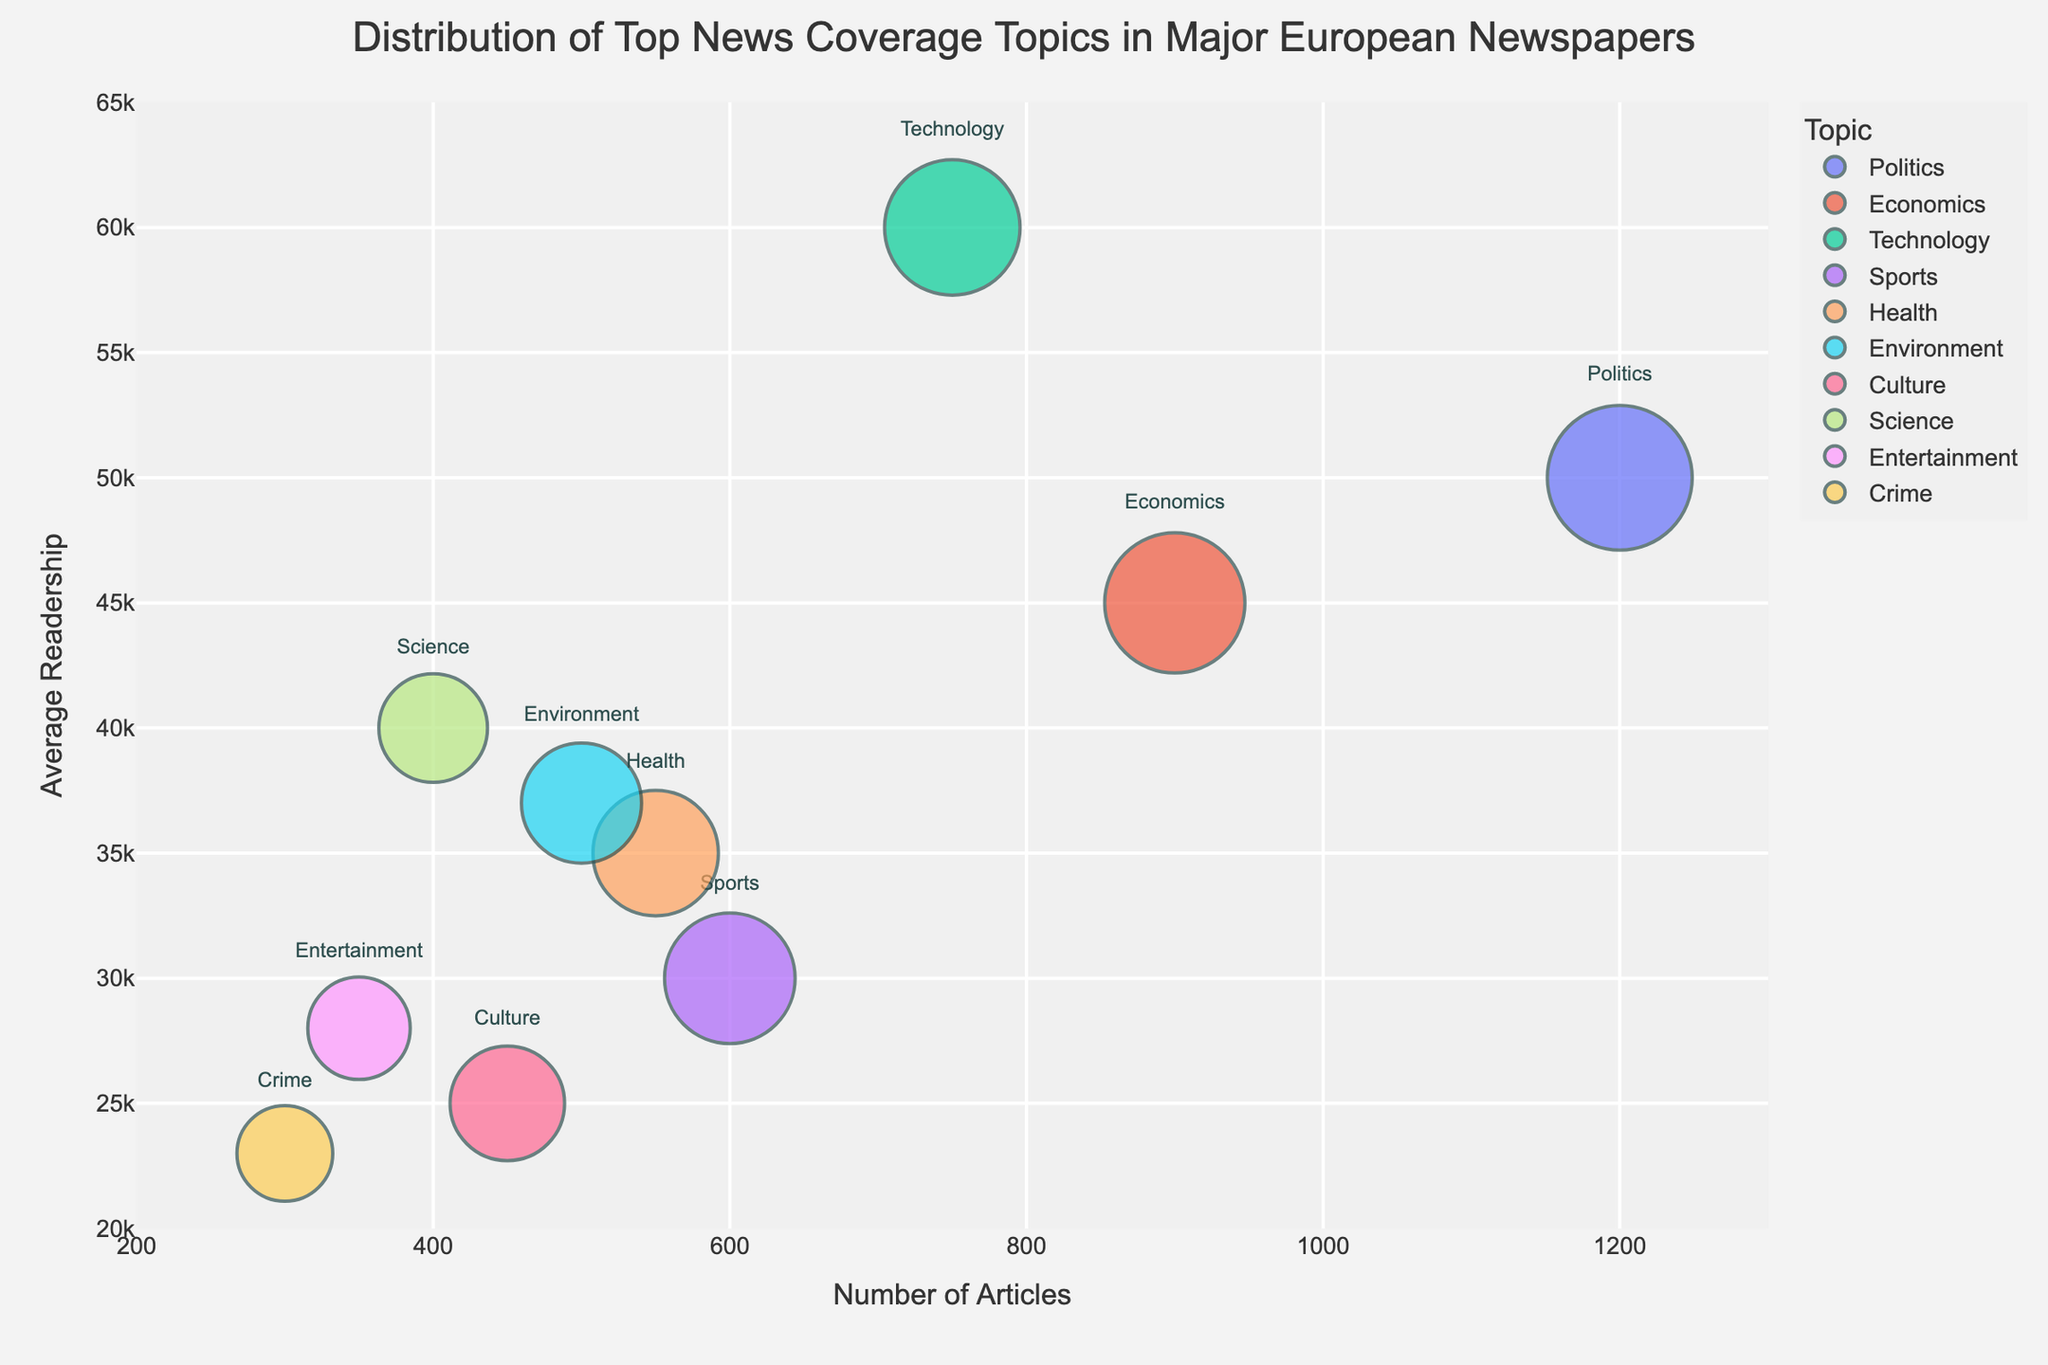what is the title of the figure? The title is usually placed at the top of the figure. In this case, it reads "Distribution of Top News Coverage Topics in Major European Newspapers".
Answer: Distribution of Top News Coverage Topics in Major European Newspapers how many topics have exactly 600 articles? Looking for the "Number of Articles" value in the figure, there is one bubble representing 'Sports' with exactly 600 articles.
Answer: 1 which topic has the highest average readership, and what is the value? To find the highest average readership, look on the y-axis. The topic 'Technology' has the highest average readership of 60,000.
Answer: Technology, 60000 what is the average impact score of 'Health' and 'Environment' topics? Firstly, note the impact scores for 'Health' (60) and 'Environment' (55). Then, calculate (60 + 55) / 2 = 57.5.
Answer: 57.5 which two topics have the closest number of articles, and what are those numbers? Look for the topics with similar x-axis values. 'Culture' and 'Science' are closest with 450 and 400 articles respectively, just 50 articles apart.
Answer: Culture (450), Science (400) how many bubbles are displayed in the figure? Each bubble represents a topic listed in the dataset. Counting them on the chart, there are 10 bubbles.
Answer: 10 which topic has the smallest impact score and what is the value? By comparing bubble sizes or checking the data hover labels, 'Crime' has the smallest impact score of 35.
Answer: Crime, 35 compare the average readership of 'Politics' and 'Economics'. Which is higher and by how much? 'Politics' has 50,000 and 'Economics' has 45,000 average readership. The difference is 50,000 - 45,000 = 5,000.
Answer: Politics by 5000 do sports articles have higher or lower average readership compared to health articles? Comparing the y-axis position of 'Sports' (30,000) and 'Health' (35,000), sports articles have lower average readership.
Answer: Lower which topic has a higher impact score: Technology or Sports? The size of the bubble indicates the impact score. 'Technology' has an impact score of 70 while 'Sports' has 65.
Answer: Technology 